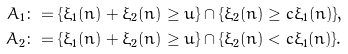Convert formula to latex. <formula><loc_0><loc_0><loc_500><loc_500>A _ { 1 } & \colon = \{ \xi _ { 1 } ( n ) + \xi _ { 2 } ( n ) \geq u \} \cap \{ \xi _ { 2 } ( n ) \geq c \xi _ { 1 } ( n ) \} , \\ A _ { 2 } & \colon = \{ \xi _ { 1 } ( n ) + \xi _ { 2 } ( n ) \geq u \} \cap \{ \xi _ { 2 } ( n ) < c \xi _ { 1 } ( n ) \} .</formula> 